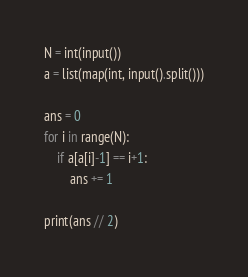Convert code to text. <code><loc_0><loc_0><loc_500><loc_500><_Python_>N = int(input())
a = list(map(int, input().split()))

ans = 0
for i in range(N):
    if a[a[i]-1] == i+1:
        ans += 1

print(ans // 2)</code> 